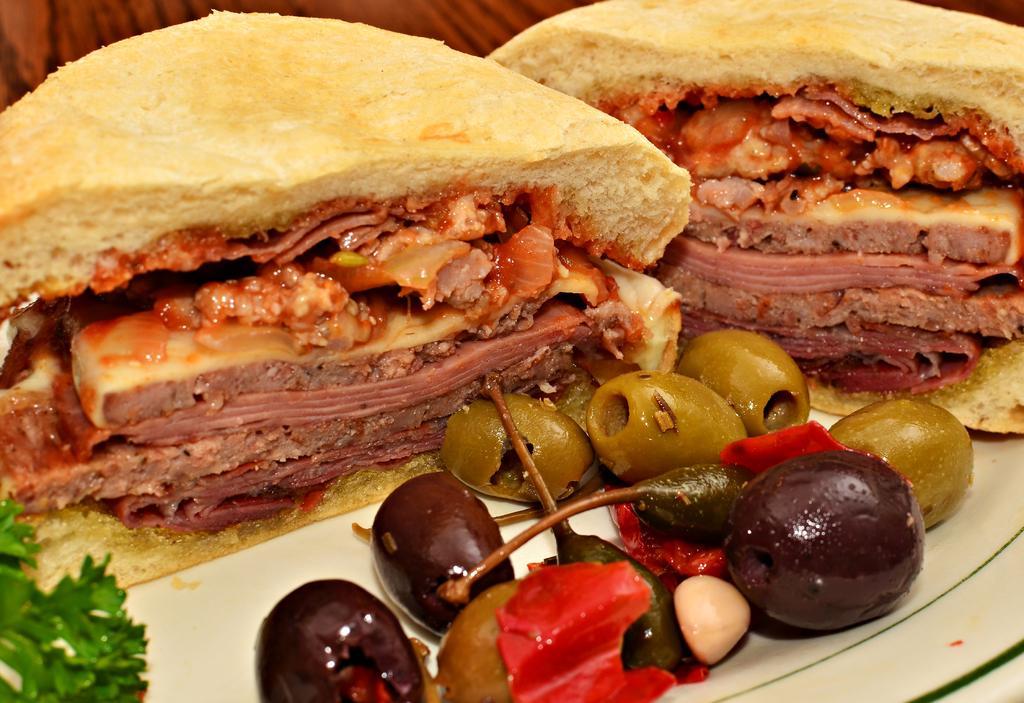In one or two sentences, can you explain what this image depicts? In this picture we can see food in the plate. 